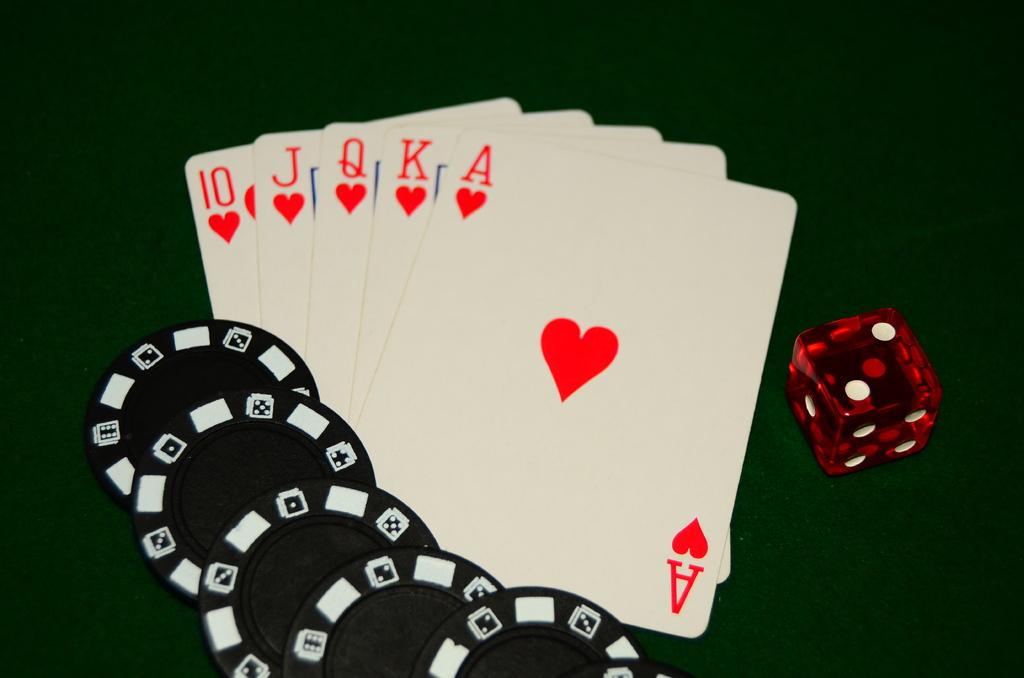How many cards are in the game?
Offer a very short reply. Answering does not require reading text in the image. Is that an ace of hearts?d?
Offer a terse response. Yes. 